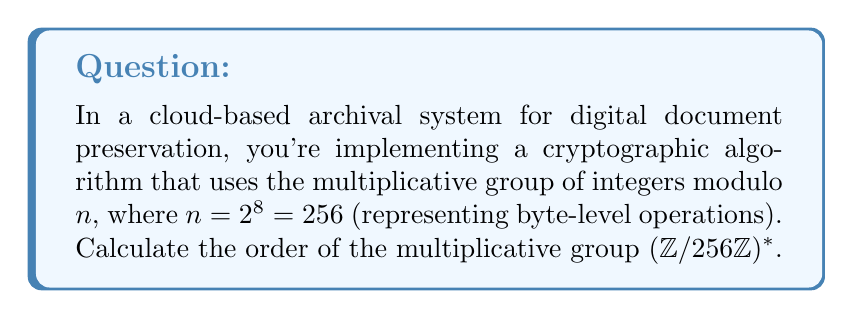Solve this math problem. To calculate the order of the multiplicative group $(\mathbb{Z}/256\mathbb{Z})^*$, we need to follow these steps:

1) First, recall that for a general modulus $n$, the order of $(\mathbb{Z}/n\mathbb{Z})^*$ is given by Euler's totient function $\phi(n)$.

2) In this case, $n = 2^8 = 256$. For prime powers $p^k$, the Euler totient function is given by:

   $$\phi(p^k) = p^k - p^{k-1} = p^k(1 - \frac{1}{p})$$

3) Applying this to our case:

   $$\phi(2^8) = 2^8 - 2^7 = 256 - 128 = 128$$

4) We can also think about this intuitively: in $(\mathbb{Z}/256\mathbb{Z})^*$, we're looking for numbers that are coprime to 256. These are all the odd numbers from 1 to 255, which is exactly half of the numbers in this range.

5) Therefore, the order of the multiplicative group $(\mathbb{Z}/256\mathbb{Z})^*$ is 128.

This result is particularly relevant for byte-level operations in cryptographic algorithms, as it determines the number of invertible elements when working with individual bytes.
Answer: The order of the multiplicative group $(\mathbb{Z}/256\mathbb{Z})^*$ is 128. 